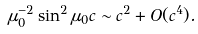<formula> <loc_0><loc_0><loc_500><loc_500>\mu _ { 0 } ^ { - 2 } \sin ^ { 2 } \mu _ { 0 } c \sim c ^ { 2 } + O ( c ^ { 4 } ) .</formula> 